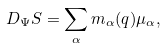Convert formula to latex. <formula><loc_0><loc_0><loc_500><loc_500>D _ { \Psi } S = \sum _ { \alpha } m _ { \alpha } ( q ) \mu _ { \alpha } ,</formula> 